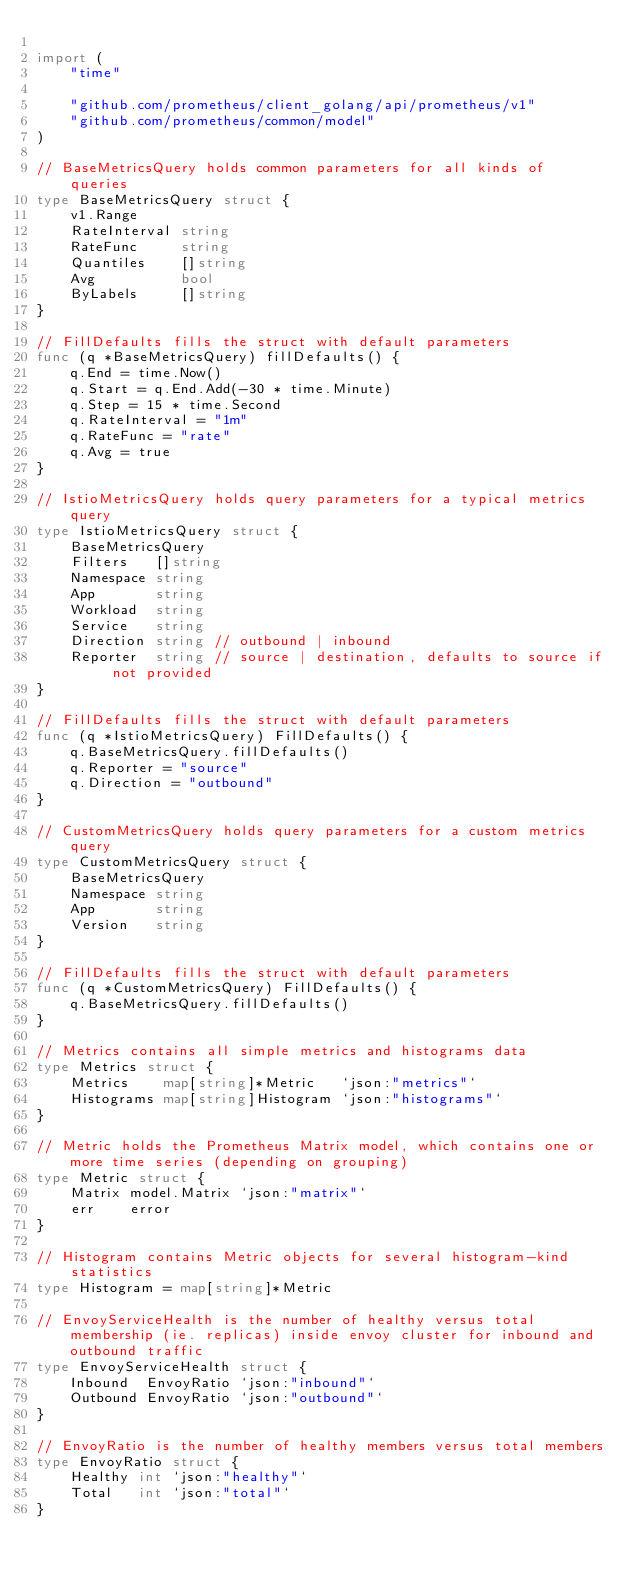Convert code to text. <code><loc_0><loc_0><loc_500><loc_500><_Go_>
import (
	"time"

	"github.com/prometheus/client_golang/api/prometheus/v1"
	"github.com/prometheus/common/model"
)

// BaseMetricsQuery holds common parameters for all kinds of queries
type BaseMetricsQuery struct {
	v1.Range
	RateInterval string
	RateFunc     string
	Quantiles    []string
	Avg          bool
	ByLabels     []string
}

// FillDefaults fills the struct with default parameters
func (q *BaseMetricsQuery) fillDefaults() {
	q.End = time.Now()
	q.Start = q.End.Add(-30 * time.Minute)
	q.Step = 15 * time.Second
	q.RateInterval = "1m"
	q.RateFunc = "rate"
	q.Avg = true
}

// IstioMetricsQuery holds query parameters for a typical metrics query
type IstioMetricsQuery struct {
	BaseMetricsQuery
	Filters   []string
	Namespace string
	App       string
	Workload  string
	Service   string
	Direction string // outbound | inbound
	Reporter  string // source | destination, defaults to source if not provided
}

// FillDefaults fills the struct with default parameters
func (q *IstioMetricsQuery) FillDefaults() {
	q.BaseMetricsQuery.fillDefaults()
	q.Reporter = "source"
	q.Direction = "outbound"
}

// CustomMetricsQuery holds query parameters for a custom metrics query
type CustomMetricsQuery struct {
	BaseMetricsQuery
	Namespace string
	App       string
	Version   string
}

// FillDefaults fills the struct with default parameters
func (q *CustomMetricsQuery) FillDefaults() {
	q.BaseMetricsQuery.fillDefaults()
}

// Metrics contains all simple metrics and histograms data
type Metrics struct {
	Metrics    map[string]*Metric   `json:"metrics"`
	Histograms map[string]Histogram `json:"histograms"`
}

// Metric holds the Prometheus Matrix model, which contains one or more time series (depending on grouping)
type Metric struct {
	Matrix model.Matrix `json:"matrix"`
	err    error
}

// Histogram contains Metric objects for several histogram-kind statistics
type Histogram = map[string]*Metric

// EnvoyServiceHealth is the number of healthy versus total membership (ie. replicas) inside envoy cluster for inbound and outbound traffic
type EnvoyServiceHealth struct {
	Inbound  EnvoyRatio `json:"inbound"`
	Outbound EnvoyRatio `json:"outbound"`
}

// EnvoyRatio is the number of healthy members versus total members
type EnvoyRatio struct {
	Healthy int `json:"healthy"`
	Total   int `json:"total"`
}
</code> 